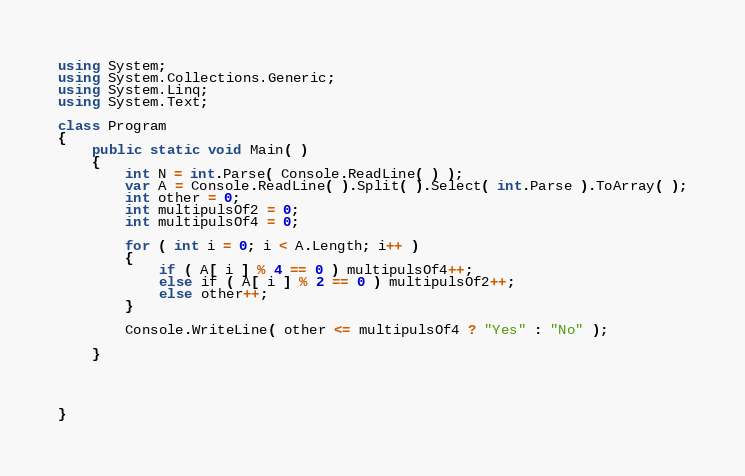<code> <loc_0><loc_0><loc_500><loc_500><_C#_>using System;
using System.Collections.Generic;
using System.Linq;
using System.Text;

class Program
{
    public static void Main( )
    {
        int N = int.Parse( Console.ReadLine( ) );
        var A = Console.ReadLine( ).Split( ).Select( int.Parse ).ToArray( );
        int other = 0;
        int multipulsOf2 = 0;
        int multipulsOf4 = 0;

        for ( int i = 0; i < A.Length; i++ )
        {
            if ( A[ i ] % 4 == 0 ) multipulsOf4++;
            else if ( A[ i ] % 2 == 0 ) multipulsOf2++;
            else other++;
        }

        Console.WriteLine( other <= multipulsOf4 ? "Yes" : "No" );

    }




}</code> 